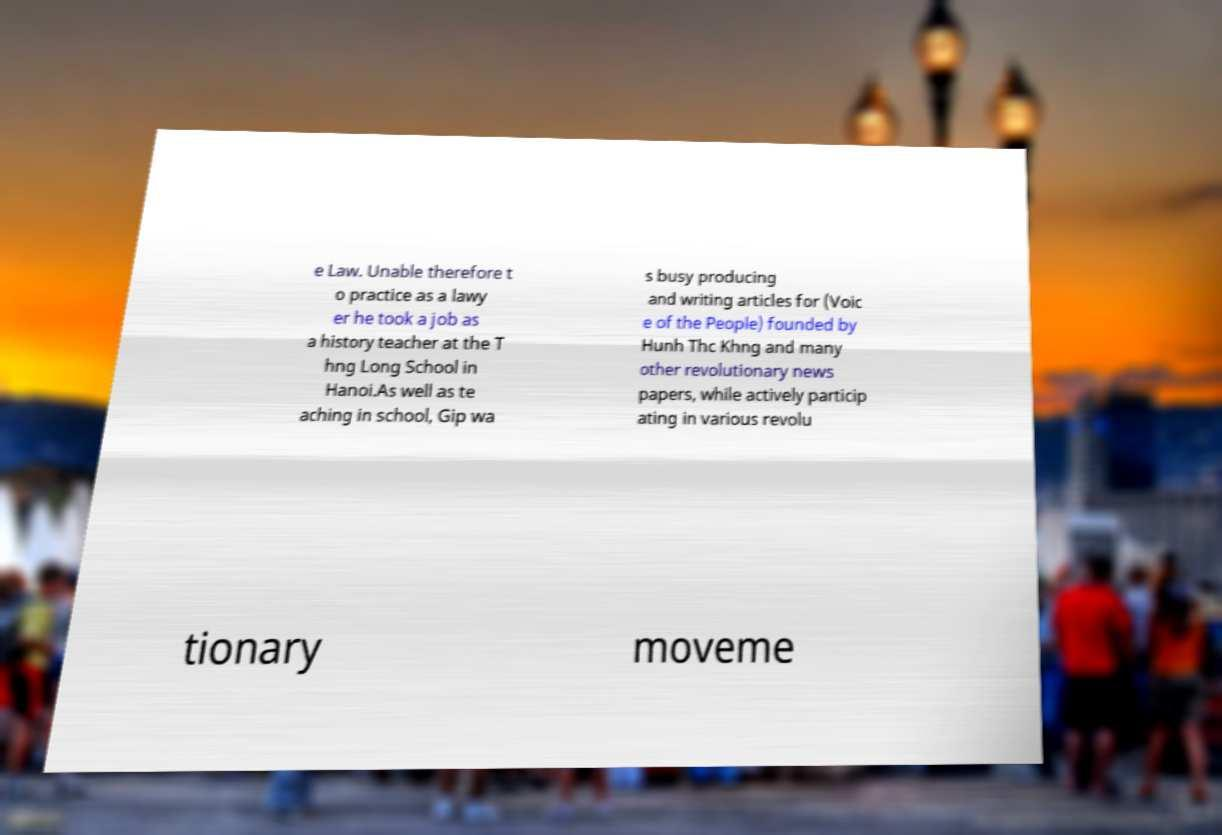What messages or text are displayed in this image? I need them in a readable, typed format. e Law. Unable therefore t o practice as a lawy er he took a job as a history teacher at the T hng Long School in Hanoi.As well as te aching in school, Gip wa s busy producing and writing articles for (Voic e of the People) founded by Hunh Thc Khng and many other revolutionary news papers, while actively particip ating in various revolu tionary moveme 